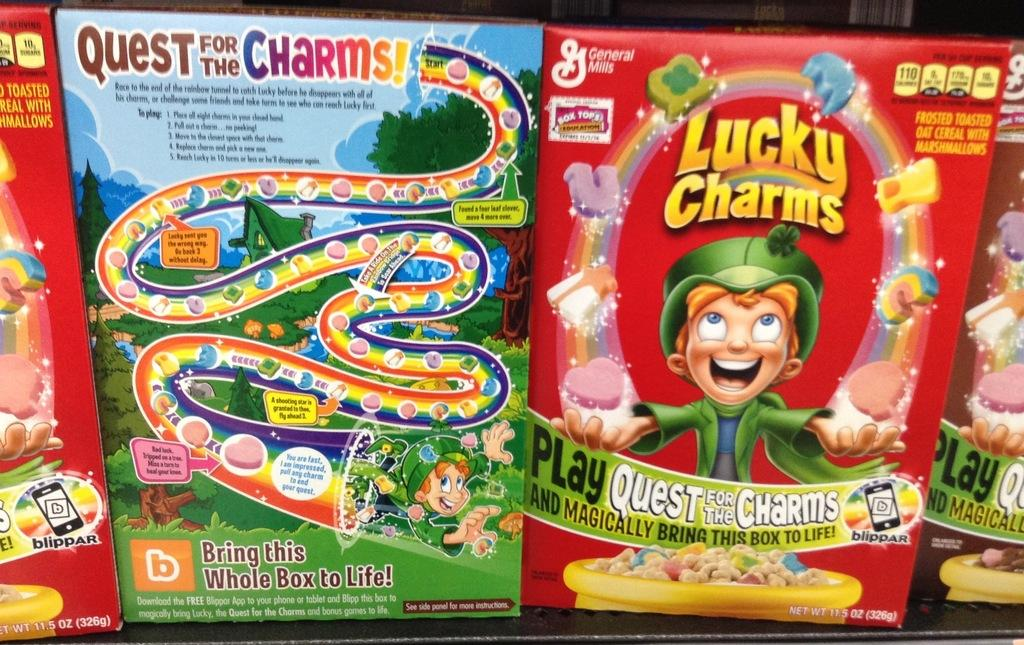What objects are present in the image? There are boxes in the image. What can be found on the surface of the boxes? The boxes have text and images on them. What type of tin can be seen sticking out of the boxes in the image? There is no tin present in the image, nor is there any indication of a tin sticking out of the boxes. 